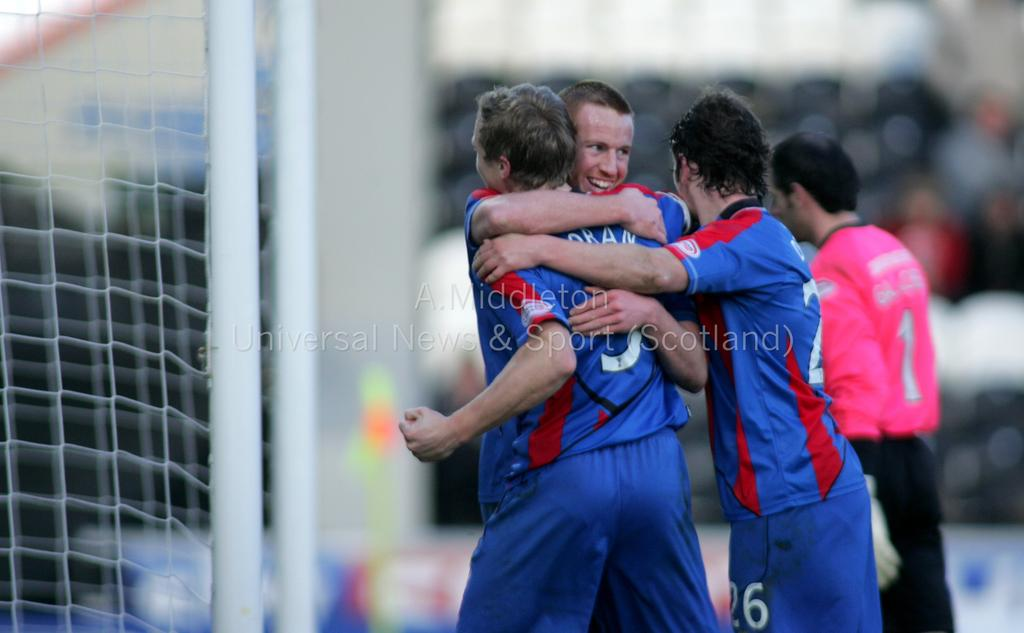<image>
Summarize the visual content of the image. A soccer player named Oran is being hugged by a teammate. 